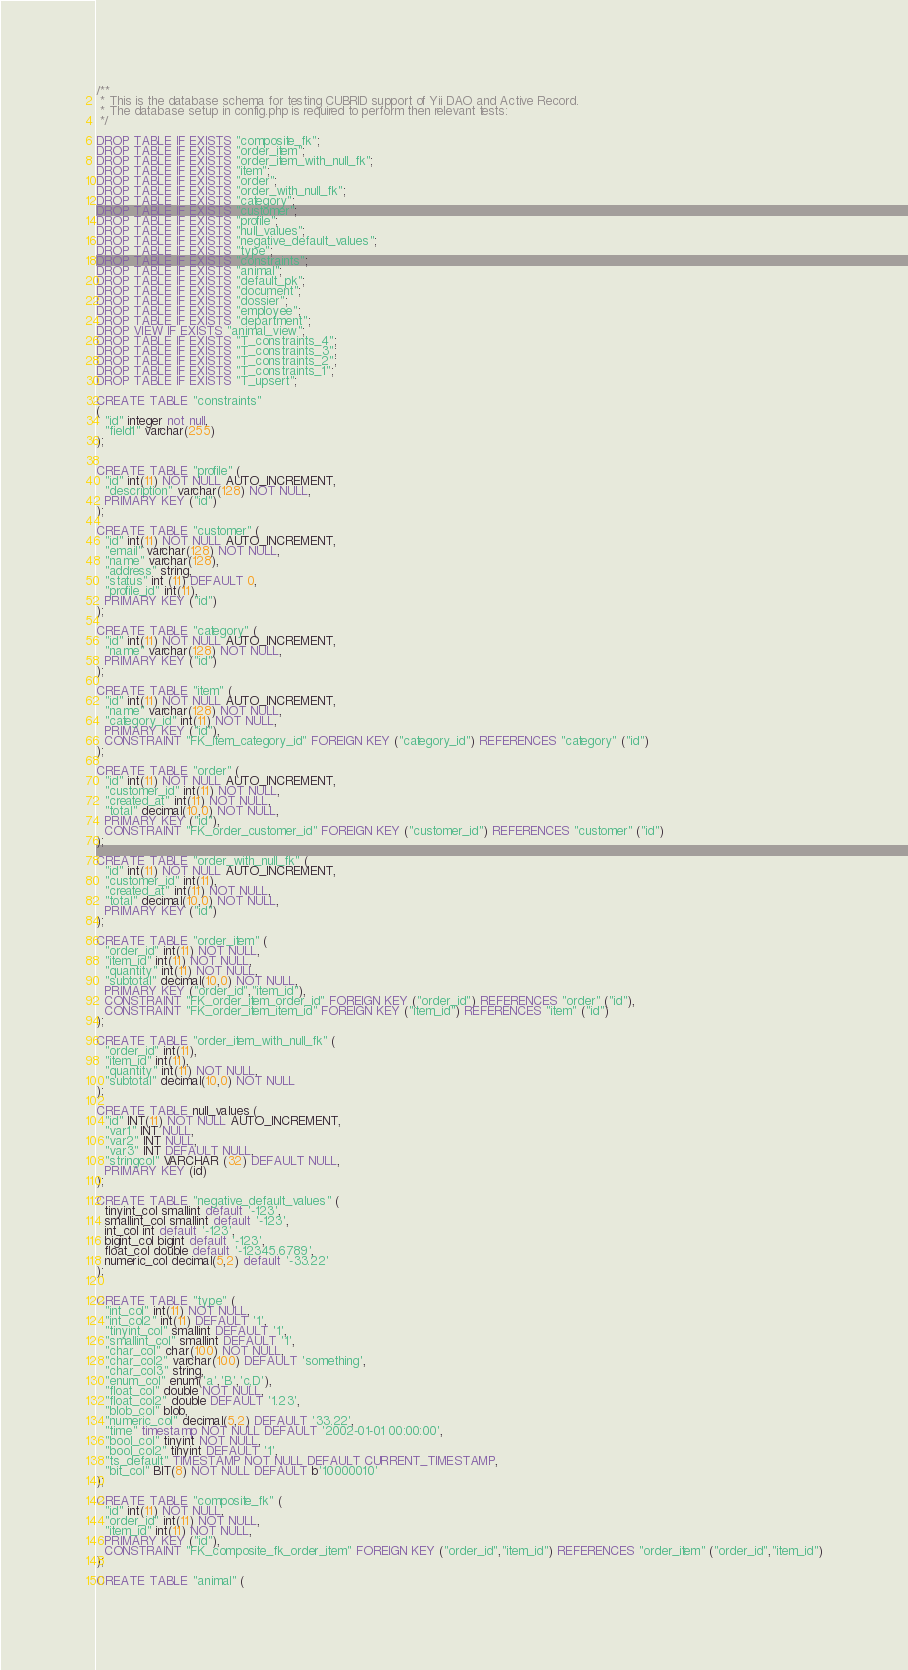<code> <loc_0><loc_0><loc_500><loc_500><_SQL_>/**
 * This is the database schema for testing CUBRID support of Yii DAO and Active Record.
 * The database setup in config.php is required to perform then relevant tests:
 */

DROP TABLE IF EXISTS "composite_fk";
DROP TABLE IF EXISTS "order_item";
DROP TABLE IF EXISTS "order_item_with_null_fk";
DROP TABLE IF EXISTS "item";
DROP TABLE IF EXISTS "order";
DROP TABLE IF EXISTS "order_with_null_fk";
DROP TABLE IF EXISTS "category";
DROP TABLE IF EXISTS "customer";
DROP TABLE IF EXISTS "profile";
DROP TABLE IF EXISTS "null_values";
DROP TABLE IF EXISTS "negative_default_values";
DROP TABLE IF EXISTS "type";
DROP TABLE IF EXISTS "constraints";
DROP TABLE IF EXISTS "animal";
DROP TABLE IF EXISTS "default_pk";
DROP TABLE IF EXISTS "document";
DROP TABLE IF EXISTS "dossier";
DROP TABLE IF EXISTS "employee";
DROP TABLE IF EXISTS "department";
DROP VIEW IF EXISTS "animal_view";
DROP TABLE IF EXISTS "T_constraints_4";
DROP TABLE IF EXISTS "T_constraints_3";
DROP TABLE IF EXISTS "T_constraints_2";
DROP TABLE IF EXISTS "T_constraints_1";
DROP TABLE IF EXISTS "T_upsert";

CREATE TABLE "constraints"
(
  "id" integer not null,
  "field1" varchar(255)
);


CREATE TABLE "profile" (
  "id" int(11) NOT NULL AUTO_INCREMENT,
  "description" varchar(128) NOT NULL,
  PRIMARY KEY ("id")
);

CREATE TABLE "customer" (
  "id" int(11) NOT NULL AUTO_INCREMENT,
  "email" varchar(128) NOT NULL,
  "name" varchar(128),
  "address" string,
  "status" int (11) DEFAULT 0,
  "profile_id" int(11),
  PRIMARY KEY ("id")
);

CREATE TABLE "category" (
  "id" int(11) NOT NULL AUTO_INCREMENT,
  "name" varchar(128) NOT NULL,
  PRIMARY KEY ("id")
);

CREATE TABLE "item" (
  "id" int(11) NOT NULL AUTO_INCREMENT,
  "name" varchar(128) NOT NULL,
  "category_id" int(11) NOT NULL,
  PRIMARY KEY ("id"),
  CONSTRAINT "FK_item_category_id" FOREIGN KEY ("category_id") REFERENCES "category" ("id")
);

CREATE TABLE "order" (
  "id" int(11) NOT NULL AUTO_INCREMENT,
  "customer_id" int(11) NOT NULL,
  "created_at" int(11) NOT NULL,
  "total" decimal(10,0) NOT NULL,
  PRIMARY KEY ("id"),
  CONSTRAINT "FK_order_customer_id" FOREIGN KEY ("customer_id") REFERENCES "customer" ("id")
);

CREATE TABLE "order_with_null_fk" (
  "id" int(11) NOT NULL AUTO_INCREMENT,
  "customer_id" int(11),
  "created_at" int(11) NOT NULL,
  "total" decimal(10,0) NOT NULL,
  PRIMARY KEY ("id")
);

CREATE TABLE "order_item" (
  "order_id" int(11) NOT NULL,
  "item_id" int(11) NOT NULL,
  "quantity" int(11) NOT NULL,
  "subtotal" decimal(10,0) NOT NULL,
  PRIMARY KEY ("order_id","item_id"),
  CONSTRAINT "FK_order_item_order_id" FOREIGN KEY ("order_id") REFERENCES "order" ("id"),
  CONSTRAINT "FK_order_item_item_id" FOREIGN KEY ("item_id") REFERENCES "item" ("id")
);

CREATE TABLE "order_item_with_null_fk" (
  "order_id" int(11),
  "item_id" int(11),
  "quantity" int(11) NOT NULL,
  "subtotal" decimal(10,0) NOT NULL
);

CREATE TABLE null_values (
  "id" INT(11) NOT NULL AUTO_INCREMENT,
  "var1" INT NULL,
  "var2" INT NULL,
  "var3" INT DEFAULT NULL,
  "stringcol" VARCHAR (32) DEFAULT NULL,
  PRIMARY KEY (id)
);

CREATE TABLE "negative_default_values" (
  tinyint_col smallint default '-123',
  smallint_col smallint default '-123',
  int_col int default '-123',
  bigint_col bigint default '-123',
  float_col double default '-12345.6789',
  numeric_col decimal(5,2) default '-33.22'
);


CREATE TABLE "type" (
  "int_col" int(11) NOT NULL,
  "int_col2" int(11) DEFAULT '1',
  "tinyint_col" smallint DEFAULT '1',
  "smallint_col" smallint DEFAULT '1',
  "char_col" char(100) NOT NULL,
  "char_col2" varchar(100) DEFAULT 'something',
  "char_col3" string,
  "enum_col" enum('a','B','c,D'),
  "float_col" double NOT NULL,
  "float_col2" double DEFAULT '1.23',
  "blob_col" blob,
  "numeric_col" decimal(5,2) DEFAULT '33.22',
  "time" timestamp NOT NULL DEFAULT '2002-01-01 00:00:00',
  "bool_col" tinyint NOT NULL,
  "bool_col2" tinyint DEFAULT '1',
  "ts_default" TIMESTAMP NOT NULL DEFAULT CURRENT_TIMESTAMP,
  "bit_col" BIT(8) NOT NULL DEFAULT b'10000010'
);

CREATE TABLE "composite_fk" (
  "id" int(11) NOT NULL,
  "order_id" int(11) NOT NULL,
  "item_id" int(11) NOT NULL,
  PRIMARY KEY ("id"),
  CONSTRAINT "FK_composite_fk_order_item" FOREIGN KEY ("order_id","item_id") REFERENCES "order_item" ("order_id","item_id")
);

CREATE TABLE "animal" (</code> 